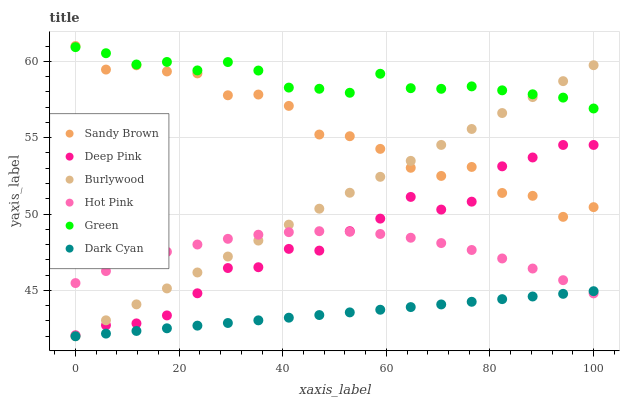Does Dark Cyan have the minimum area under the curve?
Answer yes or no. Yes. Does Green have the maximum area under the curve?
Answer yes or no. Yes. Does Burlywood have the minimum area under the curve?
Answer yes or no. No. Does Burlywood have the maximum area under the curve?
Answer yes or no. No. Is Dark Cyan the smoothest?
Answer yes or no. Yes. Is Sandy Brown the roughest?
Answer yes or no. Yes. Is Burlywood the smoothest?
Answer yes or no. No. Is Burlywood the roughest?
Answer yes or no. No. Does Burlywood have the lowest value?
Answer yes or no. Yes. Does Hot Pink have the lowest value?
Answer yes or no. No. Does Sandy Brown have the highest value?
Answer yes or no. Yes. Does Burlywood have the highest value?
Answer yes or no. No. Is Deep Pink less than Green?
Answer yes or no. Yes. Is Sandy Brown greater than Dark Cyan?
Answer yes or no. Yes. Does Hot Pink intersect Dark Cyan?
Answer yes or no. Yes. Is Hot Pink less than Dark Cyan?
Answer yes or no. No. Is Hot Pink greater than Dark Cyan?
Answer yes or no. No. Does Deep Pink intersect Green?
Answer yes or no. No. 